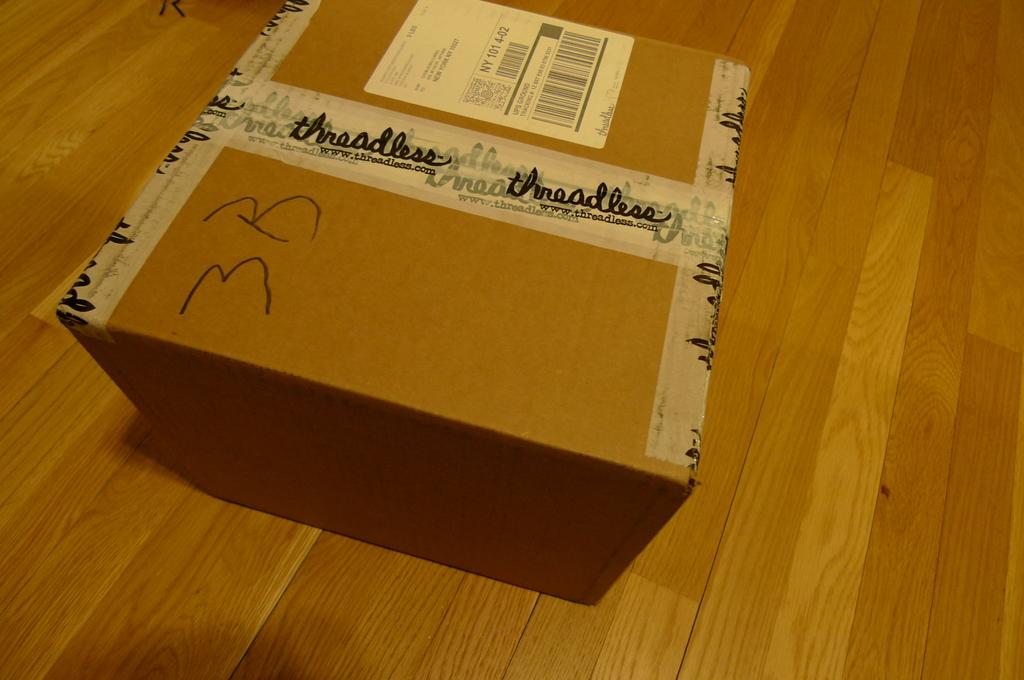What company is this box from?
Offer a terse response. Threadless. 